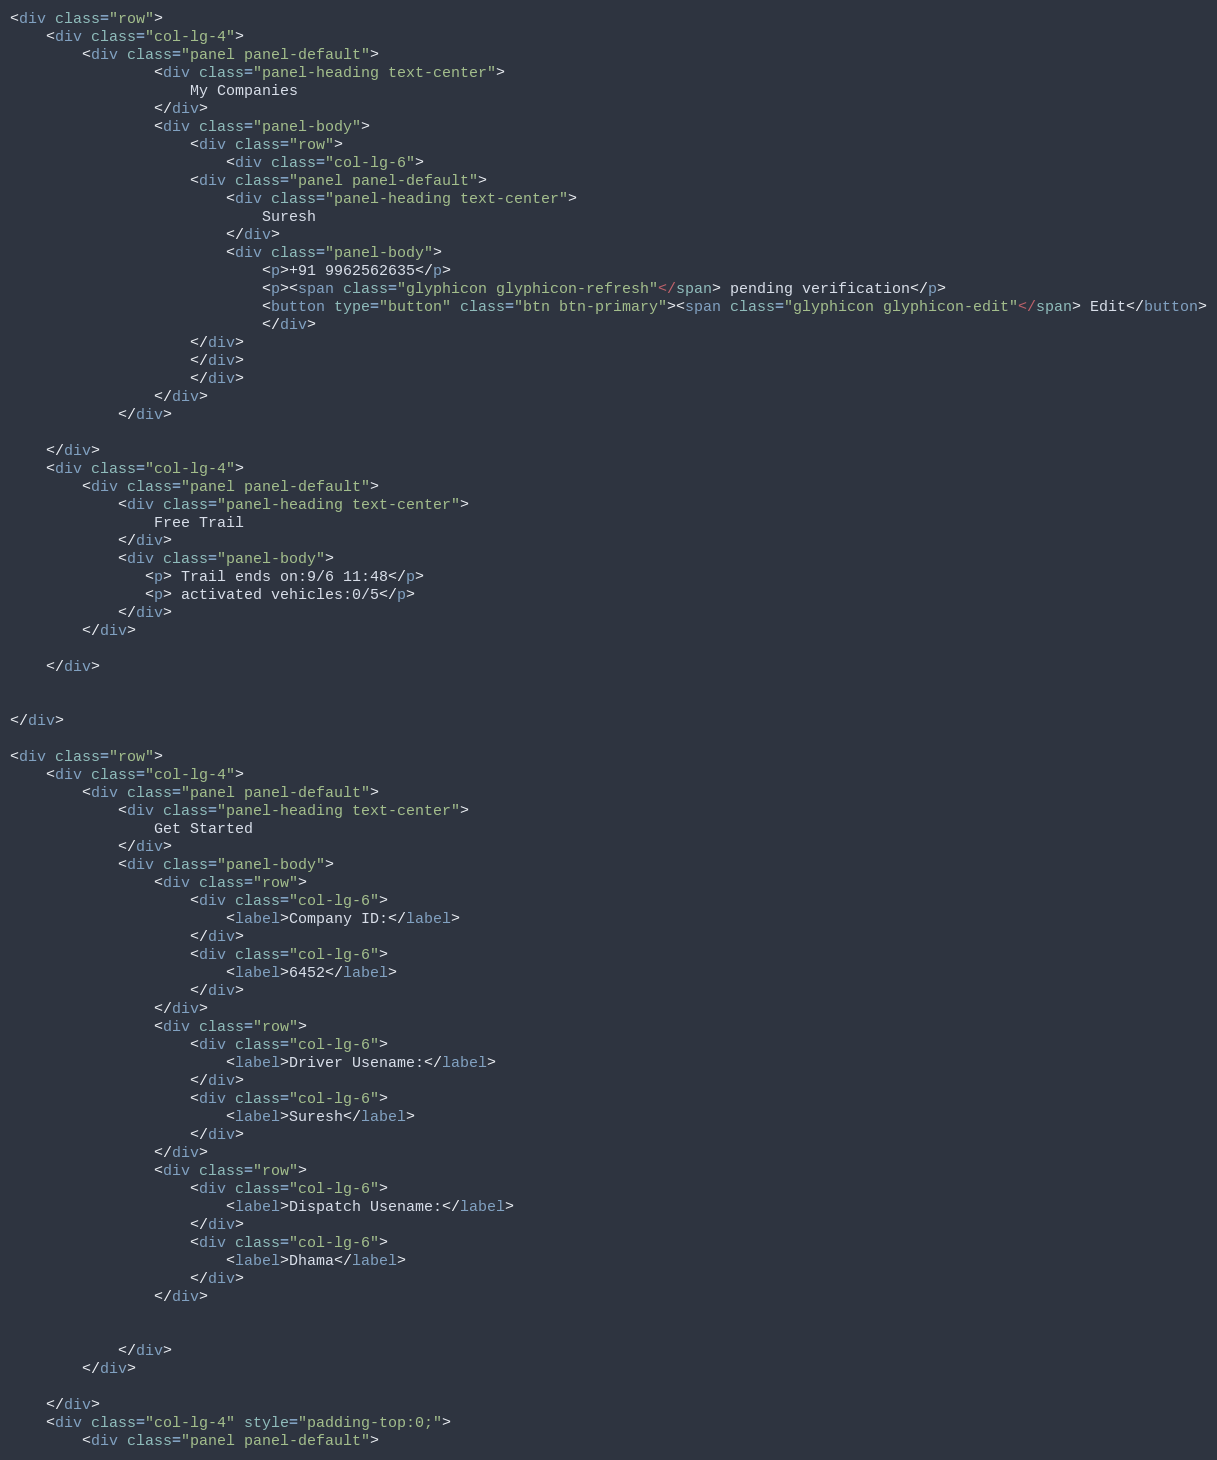<code> <loc_0><loc_0><loc_500><loc_500><_HTML_><div class="row">
    <div class="col-lg-4">
        <div class="panel panel-default">
                <div class="panel-heading text-center">
                    My Companies
                </div>
                <div class="panel-body">
                    <div class="row">
                        <div class="col-lg-6">
                    <div class="panel panel-default">
                        <div class="panel-heading text-center">
                            Suresh
                        </div>
                        <div class="panel-body">
                            <p>+91 9962562635</p>
                            <p><span class="glyphicon glyphicon-refresh"</span> pending verification</p>
                            <button type="button" class="btn btn-primary"><span class="glyphicon glyphicon-edit"</span> Edit</button>
                            </div>
                    </div>
                    </div>
                    </div>
                </div>
            </div>

    </div>
    <div class="col-lg-4">
        <div class="panel panel-default">
            <div class="panel-heading text-center">
                Free Trail
            </div>
            <div class="panel-body">
               <p> Trail ends on:9/6 11:48</p>
               <p> activated vehicles:0/5</p>
            </div>
        </div>

    </div>


</div>

<div class="row">
    <div class="col-lg-4">
        <div class="panel panel-default">
            <div class="panel-heading text-center">
                Get Started
            </div>
            <div class="panel-body">
                <div class="row">
                    <div class="col-lg-6">
                        <label>Company ID:</label>
                    </div>
                    <div class="col-lg-6">
                        <label>6452</label>
                    </div>
                </div>
                <div class="row">
                    <div class="col-lg-6">
                        <label>Driver Usename:</label>
                    </div>
                    <div class="col-lg-6">
                        <label>Suresh</label>
                    </div>
                </div>
                <div class="row">
                    <div class="col-lg-6">
                        <label>Dispatch Usename:</label>
                    </div>
                    <div class="col-lg-6">
                        <label>Dhama</label>
                    </div>
                </div>


            </div>
        </div>

    </div>
    <div class="col-lg-4" style="padding-top:0;">
        <div class="panel panel-default"></code> 